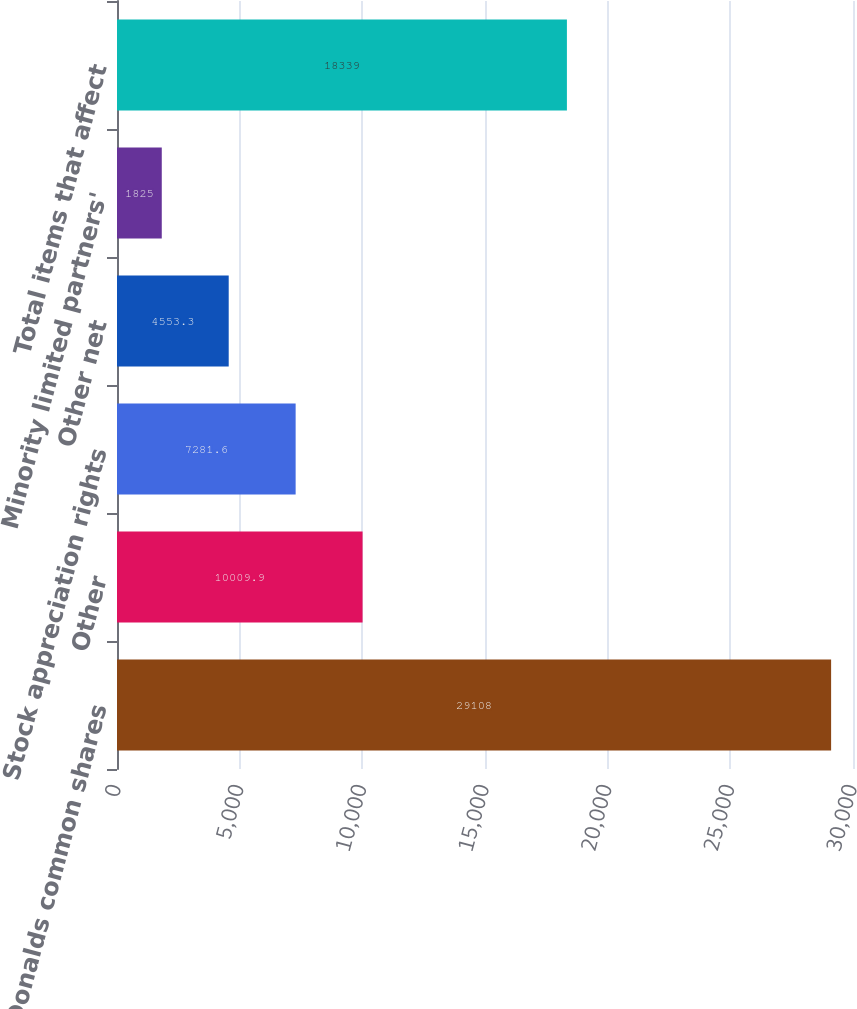Convert chart. <chart><loc_0><loc_0><loc_500><loc_500><bar_chart><fcel>McDonalds common shares<fcel>Other<fcel>Stock appreciation rights<fcel>Other net<fcel>Minority limited partners'<fcel>Total items that affect<nl><fcel>29108<fcel>10009.9<fcel>7281.6<fcel>4553.3<fcel>1825<fcel>18339<nl></chart> 